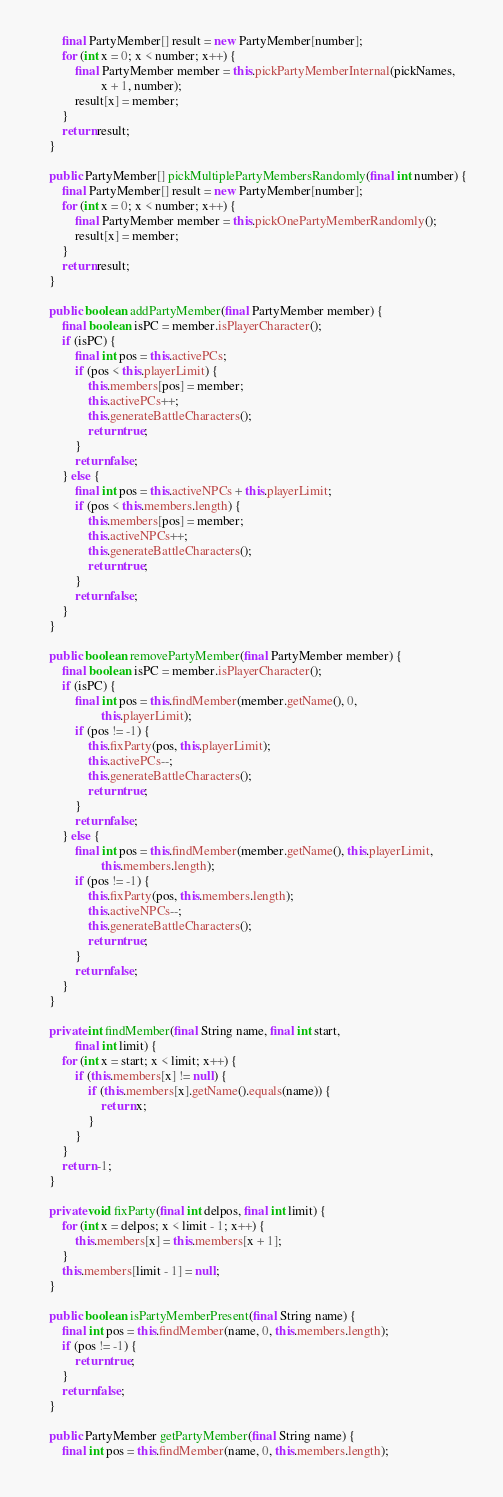Convert code to text. <code><loc_0><loc_0><loc_500><loc_500><_Java_>        final PartyMember[] result = new PartyMember[number];
        for (int x = 0; x < number; x++) {
            final PartyMember member = this.pickPartyMemberInternal(pickNames,
                    x + 1, number);
            result[x] = member;
        }
        return result;
    }

    public PartyMember[] pickMultiplePartyMembersRandomly(final int number) {
        final PartyMember[] result = new PartyMember[number];
        for (int x = 0; x < number; x++) {
            final PartyMember member = this.pickOnePartyMemberRandomly();
            result[x] = member;
        }
        return result;
    }

    public boolean addPartyMember(final PartyMember member) {
        final boolean isPC = member.isPlayerCharacter();
        if (isPC) {
            final int pos = this.activePCs;
            if (pos < this.playerLimit) {
                this.members[pos] = member;
                this.activePCs++;
                this.generateBattleCharacters();
                return true;
            }
            return false;
        } else {
            final int pos = this.activeNPCs + this.playerLimit;
            if (pos < this.members.length) {
                this.members[pos] = member;
                this.activeNPCs++;
                this.generateBattleCharacters();
                return true;
            }
            return false;
        }
    }

    public boolean removePartyMember(final PartyMember member) {
        final boolean isPC = member.isPlayerCharacter();
        if (isPC) {
            final int pos = this.findMember(member.getName(), 0,
                    this.playerLimit);
            if (pos != -1) {
                this.fixParty(pos, this.playerLimit);
                this.activePCs--;
                this.generateBattleCharacters();
                return true;
            }
            return false;
        } else {
            final int pos = this.findMember(member.getName(), this.playerLimit,
                    this.members.length);
            if (pos != -1) {
                this.fixParty(pos, this.members.length);
                this.activeNPCs--;
                this.generateBattleCharacters();
                return true;
            }
            return false;
        }
    }

    private int findMember(final String name, final int start,
            final int limit) {
        for (int x = start; x < limit; x++) {
            if (this.members[x] != null) {
                if (this.members[x].getName().equals(name)) {
                    return x;
                }
            }
        }
        return -1;
    }

    private void fixParty(final int delpos, final int limit) {
        for (int x = delpos; x < limit - 1; x++) {
            this.members[x] = this.members[x + 1];
        }
        this.members[limit - 1] = null;
    }

    public boolean isPartyMemberPresent(final String name) {
        final int pos = this.findMember(name, 0, this.members.length);
        if (pos != -1) {
            return true;
        }
        return false;
    }

    public PartyMember getPartyMember(final String name) {
        final int pos = this.findMember(name, 0, this.members.length);</code> 